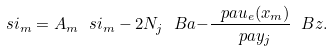<formula> <loc_0><loc_0><loc_500><loc_500>\ s i _ { m } = A _ { m } \ s i _ { m } - 2 N _ { j } \ B a { - } \frac { \ p a u _ { e } ( x _ { m } ) } { \ p a y _ { j } } \ B z .</formula> 